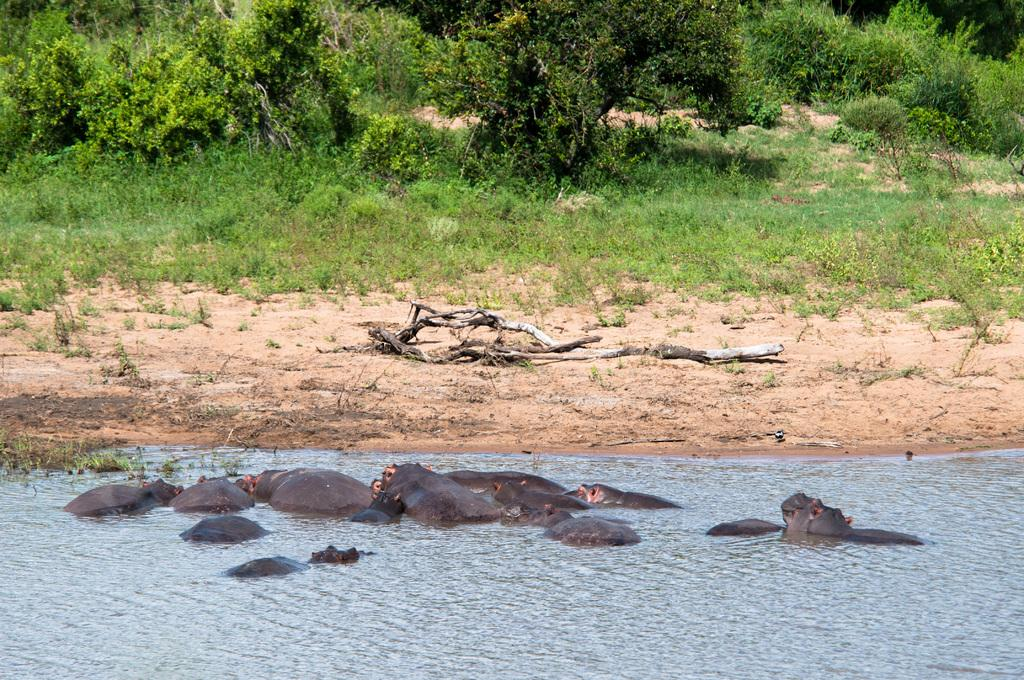What type of animals can be seen in the image? There are animals in the water. What can be seen in the background of the image? There is grass and plants visible in the background. Are there any wooden objects present in the image? Yes, there are wooden objects on the ground in the background. Where is the playground located in the image? There is no playground present in the image. What type of seat can be seen in the image? There is no seat visible in the image. 